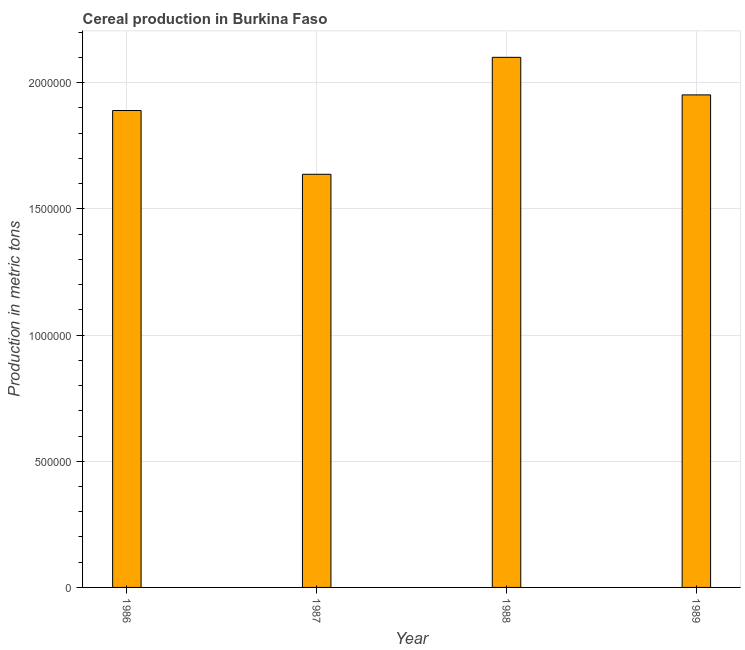Does the graph contain grids?
Offer a terse response. Yes. What is the title of the graph?
Make the answer very short. Cereal production in Burkina Faso. What is the label or title of the X-axis?
Your response must be concise. Year. What is the label or title of the Y-axis?
Make the answer very short. Production in metric tons. What is the cereal production in 1988?
Your answer should be very brief. 2.10e+06. Across all years, what is the maximum cereal production?
Give a very brief answer. 2.10e+06. Across all years, what is the minimum cereal production?
Keep it short and to the point. 1.64e+06. In which year was the cereal production maximum?
Keep it short and to the point. 1988. In which year was the cereal production minimum?
Your answer should be very brief. 1987. What is the sum of the cereal production?
Your answer should be very brief. 7.58e+06. What is the difference between the cereal production in 1986 and 1987?
Ensure brevity in your answer.  2.53e+05. What is the average cereal production per year?
Your response must be concise. 1.89e+06. What is the median cereal production?
Offer a very short reply. 1.92e+06. In how many years, is the cereal production greater than 1200000 metric tons?
Your answer should be very brief. 4. Do a majority of the years between 1988 and 1989 (inclusive) have cereal production greater than 1200000 metric tons?
Provide a short and direct response. Yes. What is the difference between the highest and the second highest cereal production?
Make the answer very short. 1.49e+05. What is the difference between the highest and the lowest cereal production?
Ensure brevity in your answer.  4.63e+05. In how many years, is the cereal production greater than the average cereal production taken over all years?
Your answer should be very brief. 2. How many bars are there?
Keep it short and to the point. 4. What is the difference between two consecutive major ticks on the Y-axis?
Your answer should be compact. 5.00e+05. What is the Production in metric tons of 1986?
Give a very brief answer. 1.89e+06. What is the Production in metric tons in 1987?
Provide a short and direct response. 1.64e+06. What is the Production in metric tons of 1988?
Keep it short and to the point. 2.10e+06. What is the Production in metric tons of 1989?
Provide a short and direct response. 1.95e+06. What is the difference between the Production in metric tons in 1986 and 1987?
Provide a succinct answer. 2.53e+05. What is the difference between the Production in metric tons in 1986 and 1988?
Make the answer very short. -2.11e+05. What is the difference between the Production in metric tons in 1986 and 1989?
Provide a short and direct response. -6.18e+04. What is the difference between the Production in metric tons in 1987 and 1988?
Offer a very short reply. -4.63e+05. What is the difference between the Production in metric tons in 1987 and 1989?
Offer a very short reply. -3.15e+05. What is the difference between the Production in metric tons in 1988 and 1989?
Provide a succinct answer. 1.49e+05. What is the ratio of the Production in metric tons in 1986 to that in 1987?
Ensure brevity in your answer.  1.15. What is the ratio of the Production in metric tons in 1986 to that in 1989?
Keep it short and to the point. 0.97. What is the ratio of the Production in metric tons in 1987 to that in 1988?
Keep it short and to the point. 0.78. What is the ratio of the Production in metric tons in 1987 to that in 1989?
Your answer should be compact. 0.84. What is the ratio of the Production in metric tons in 1988 to that in 1989?
Offer a very short reply. 1.08. 